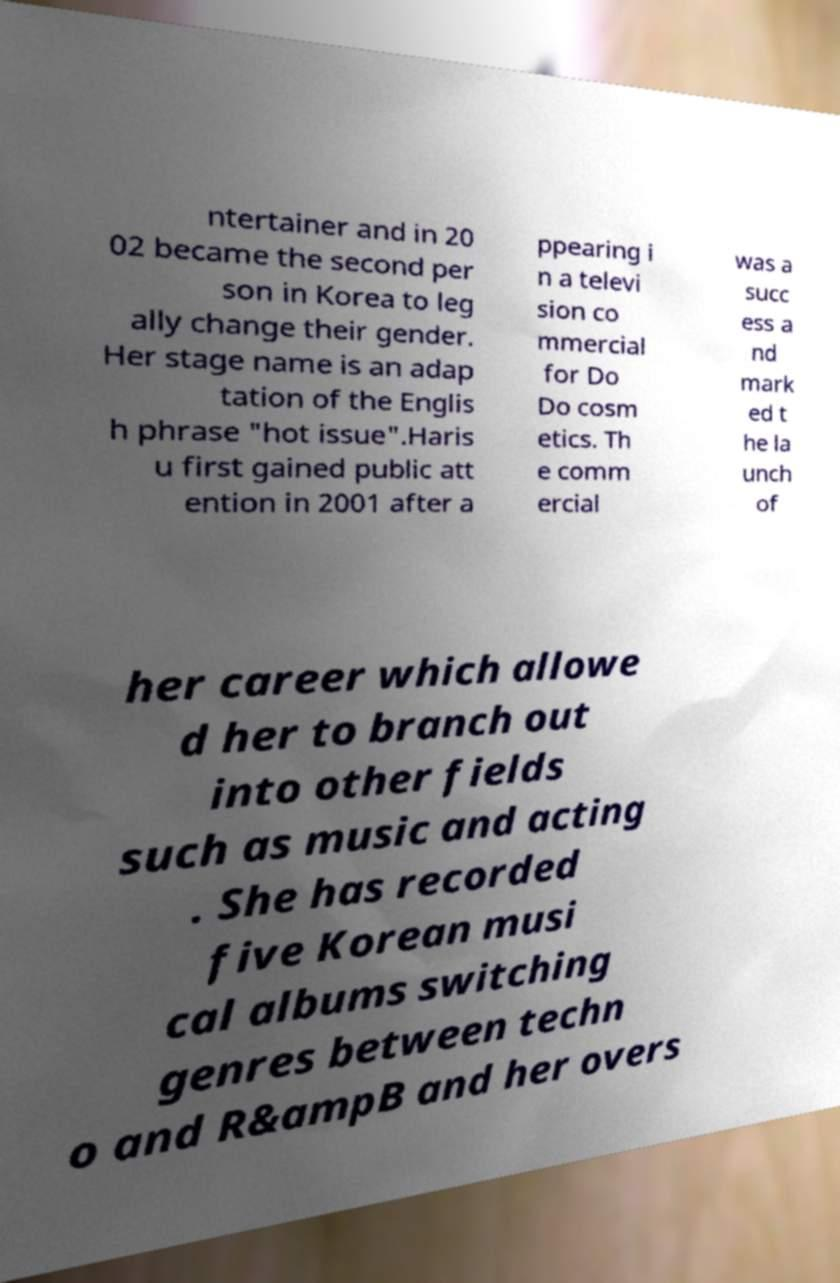Please identify and transcribe the text found in this image. ntertainer and in 20 02 became the second per son in Korea to leg ally change their gender. Her stage name is an adap tation of the Englis h phrase "hot issue".Haris u first gained public att ention in 2001 after a ppearing i n a televi sion co mmercial for Do Do cosm etics. Th e comm ercial was a succ ess a nd mark ed t he la unch of her career which allowe d her to branch out into other fields such as music and acting . She has recorded five Korean musi cal albums switching genres between techn o and R&ampB and her overs 